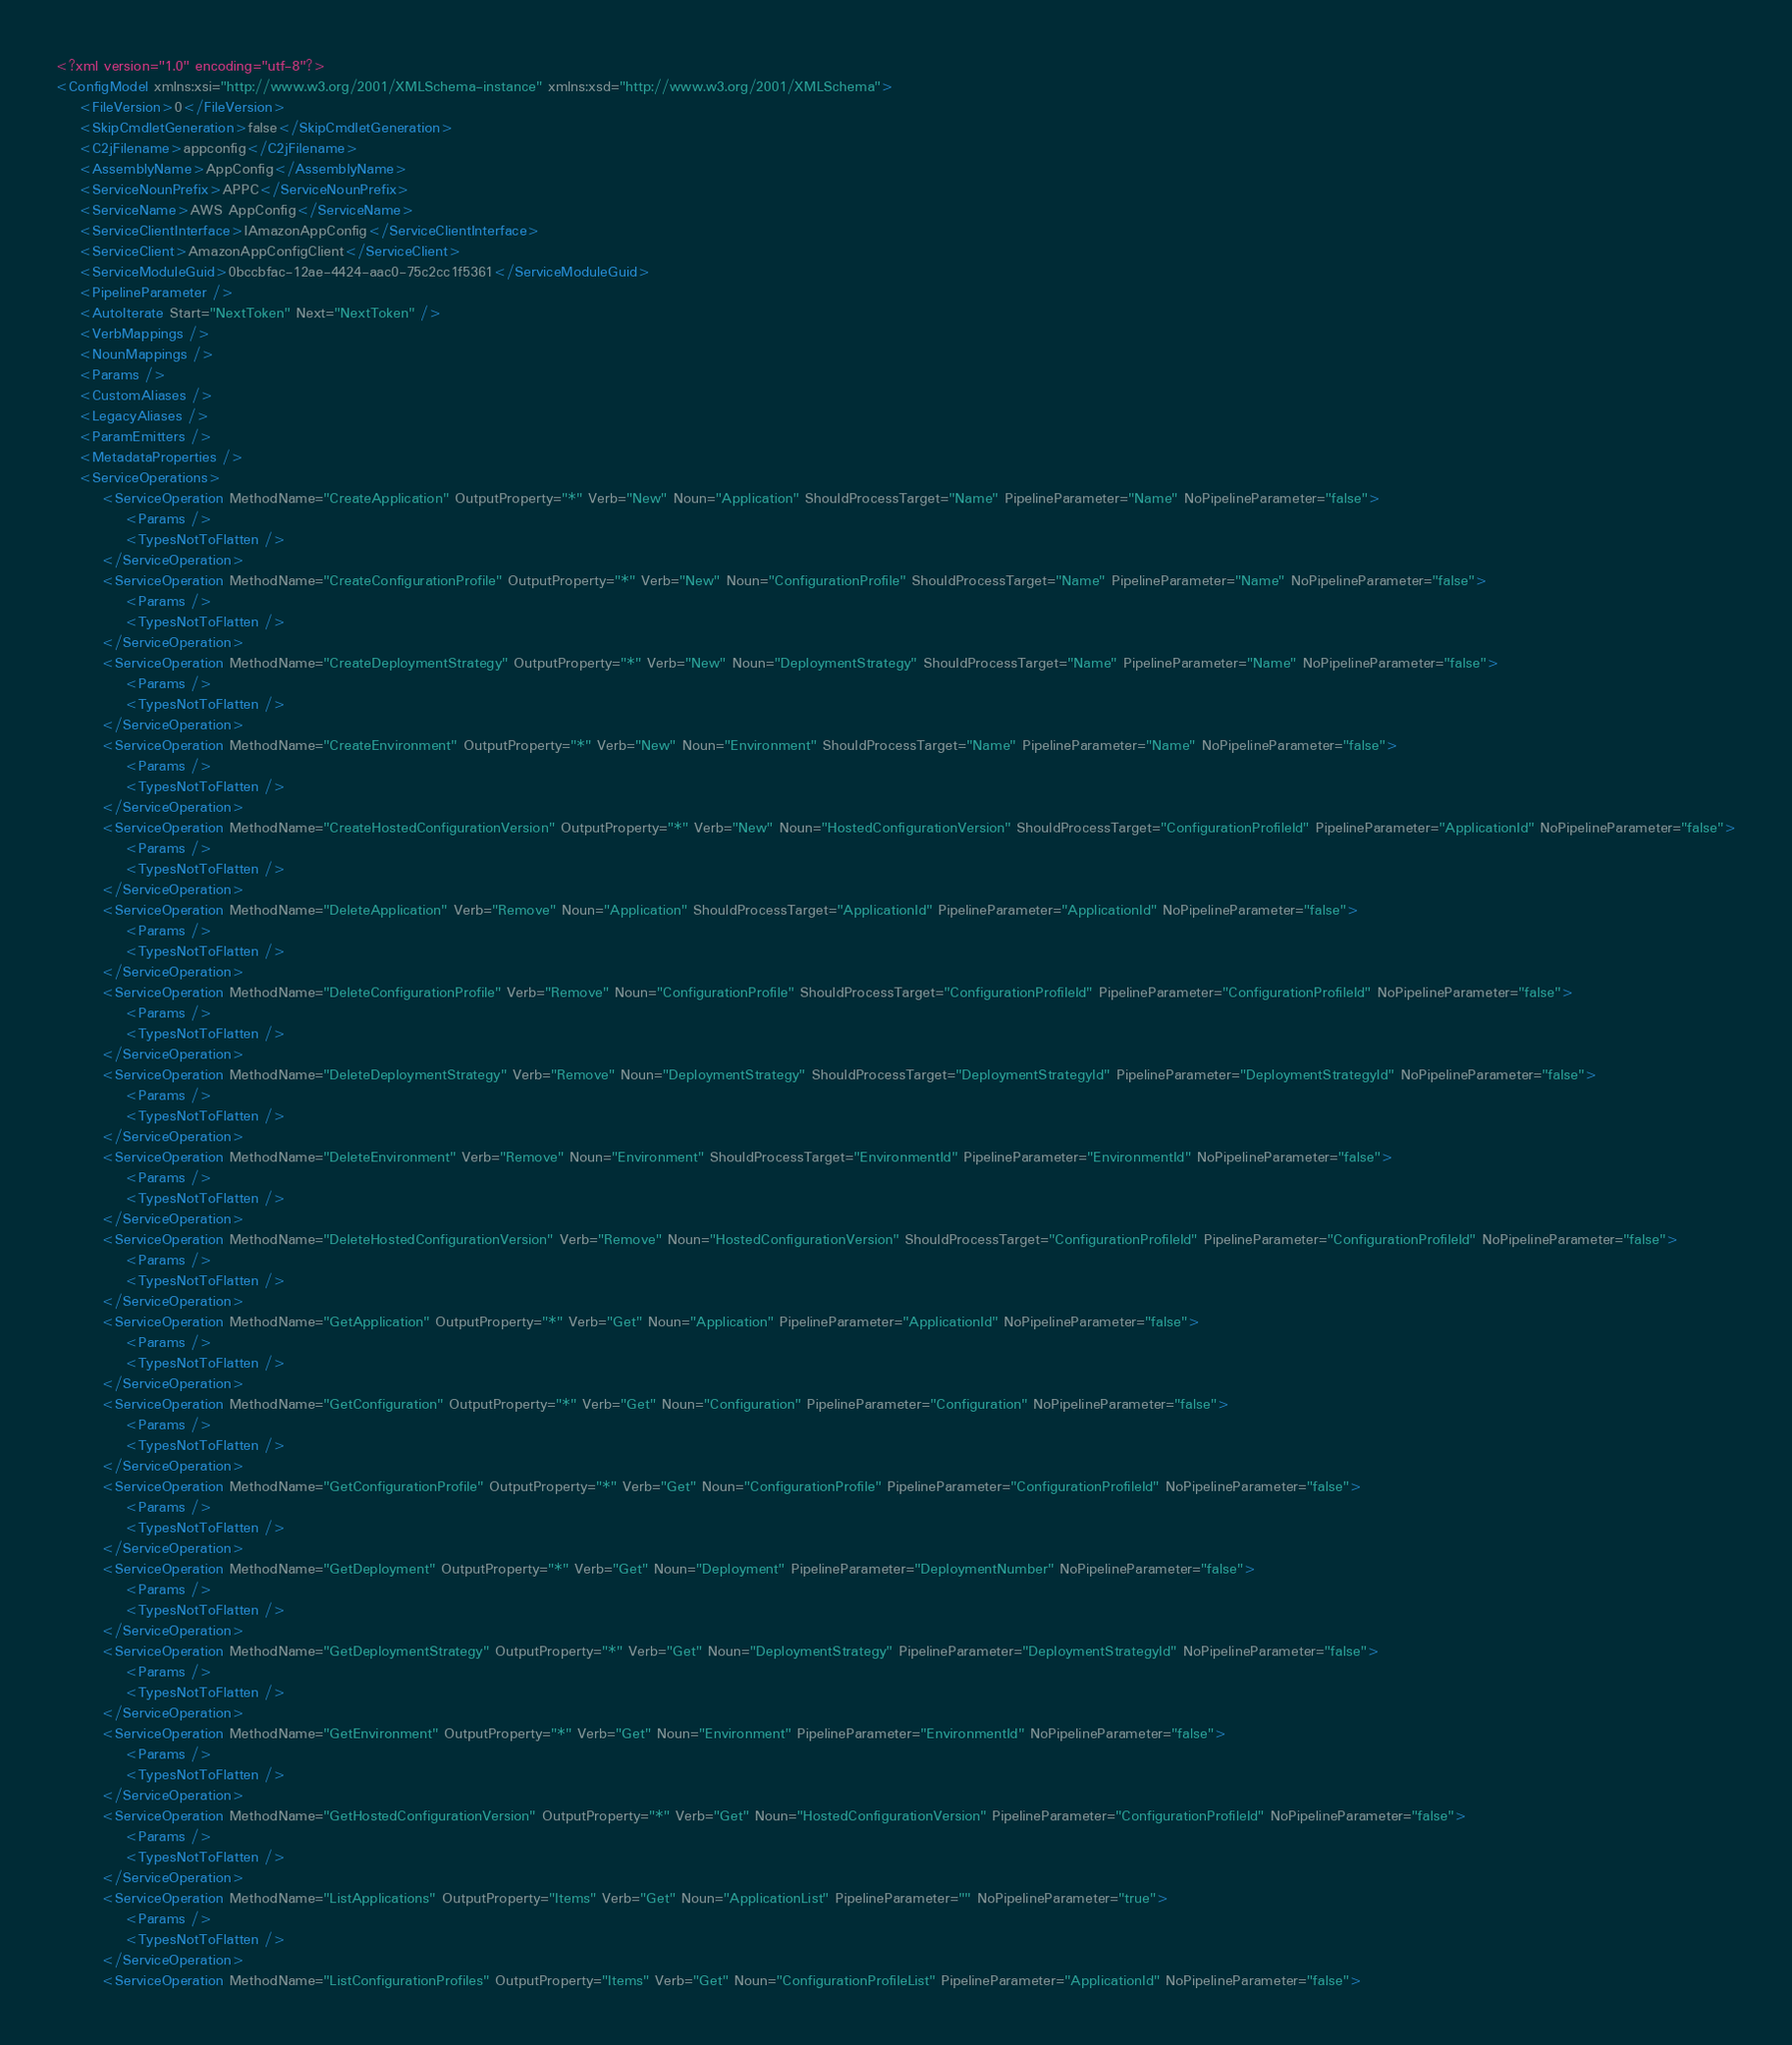<code> <loc_0><loc_0><loc_500><loc_500><_XML_><?xml version="1.0" encoding="utf-8"?>
<ConfigModel xmlns:xsi="http://www.w3.org/2001/XMLSchema-instance" xmlns:xsd="http://www.w3.org/2001/XMLSchema">
    <FileVersion>0</FileVersion>
    <SkipCmdletGeneration>false</SkipCmdletGeneration>
    <C2jFilename>appconfig</C2jFilename>
    <AssemblyName>AppConfig</AssemblyName>
    <ServiceNounPrefix>APPC</ServiceNounPrefix>
    <ServiceName>AWS AppConfig</ServiceName>
    <ServiceClientInterface>IAmazonAppConfig</ServiceClientInterface>
    <ServiceClient>AmazonAppConfigClient</ServiceClient>
    <ServiceModuleGuid>0bccbfac-12ae-4424-aac0-75c2cc1f5361</ServiceModuleGuid>
    <PipelineParameter />
    <AutoIterate Start="NextToken" Next="NextToken" />
    <VerbMappings />
    <NounMappings />
    <Params />
    <CustomAliases />
    <LegacyAliases />
    <ParamEmitters />
    <MetadataProperties />
    <ServiceOperations>
        <ServiceOperation MethodName="CreateApplication" OutputProperty="*" Verb="New" Noun="Application" ShouldProcessTarget="Name" PipelineParameter="Name" NoPipelineParameter="false">
            <Params />
            <TypesNotToFlatten />
        </ServiceOperation>
        <ServiceOperation MethodName="CreateConfigurationProfile" OutputProperty="*" Verb="New" Noun="ConfigurationProfile" ShouldProcessTarget="Name" PipelineParameter="Name" NoPipelineParameter="false">
            <Params />
            <TypesNotToFlatten />
        </ServiceOperation>
        <ServiceOperation MethodName="CreateDeploymentStrategy" OutputProperty="*" Verb="New" Noun="DeploymentStrategy" ShouldProcessTarget="Name" PipelineParameter="Name" NoPipelineParameter="false">
            <Params />
            <TypesNotToFlatten />
        </ServiceOperation>
        <ServiceOperation MethodName="CreateEnvironment" OutputProperty="*" Verb="New" Noun="Environment" ShouldProcessTarget="Name" PipelineParameter="Name" NoPipelineParameter="false">
            <Params />
            <TypesNotToFlatten />
        </ServiceOperation>
        <ServiceOperation MethodName="CreateHostedConfigurationVersion" OutputProperty="*" Verb="New" Noun="HostedConfigurationVersion" ShouldProcessTarget="ConfigurationProfileId" PipelineParameter="ApplicationId" NoPipelineParameter="false">
            <Params />
            <TypesNotToFlatten />
        </ServiceOperation>
        <ServiceOperation MethodName="DeleteApplication" Verb="Remove" Noun="Application" ShouldProcessTarget="ApplicationId" PipelineParameter="ApplicationId" NoPipelineParameter="false">
            <Params />
            <TypesNotToFlatten />
        </ServiceOperation>
        <ServiceOperation MethodName="DeleteConfigurationProfile" Verb="Remove" Noun="ConfigurationProfile" ShouldProcessTarget="ConfigurationProfileId" PipelineParameter="ConfigurationProfileId" NoPipelineParameter="false">
            <Params />
            <TypesNotToFlatten />
        </ServiceOperation>
        <ServiceOperation MethodName="DeleteDeploymentStrategy" Verb="Remove" Noun="DeploymentStrategy" ShouldProcessTarget="DeploymentStrategyId" PipelineParameter="DeploymentStrategyId" NoPipelineParameter="false">
            <Params />
            <TypesNotToFlatten />
        </ServiceOperation>
        <ServiceOperation MethodName="DeleteEnvironment" Verb="Remove" Noun="Environment" ShouldProcessTarget="EnvironmentId" PipelineParameter="EnvironmentId" NoPipelineParameter="false">
            <Params />
            <TypesNotToFlatten />
        </ServiceOperation>
        <ServiceOperation MethodName="DeleteHostedConfigurationVersion" Verb="Remove" Noun="HostedConfigurationVersion" ShouldProcessTarget="ConfigurationProfileId" PipelineParameter="ConfigurationProfileId" NoPipelineParameter="false">
            <Params />
            <TypesNotToFlatten />
        </ServiceOperation>
        <ServiceOperation MethodName="GetApplication" OutputProperty="*" Verb="Get" Noun="Application" PipelineParameter="ApplicationId" NoPipelineParameter="false">
            <Params />
            <TypesNotToFlatten />
        </ServiceOperation>
        <ServiceOperation MethodName="GetConfiguration" OutputProperty="*" Verb="Get" Noun="Configuration" PipelineParameter="Configuration" NoPipelineParameter="false">
            <Params />
            <TypesNotToFlatten />
        </ServiceOperation>
        <ServiceOperation MethodName="GetConfigurationProfile" OutputProperty="*" Verb="Get" Noun="ConfigurationProfile" PipelineParameter="ConfigurationProfileId" NoPipelineParameter="false">
            <Params />
            <TypesNotToFlatten />
        </ServiceOperation>
        <ServiceOperation MethodName="GetDeployment" OutputProperty="*" Verb="Get" Noun="Deployment" PipelineParameter="DeploymentNumber" NoPipelineParameter="false">
            <Params />
            <TypesNotToFlatten />
        </ServiceOperation>
        <ServiceOperation MethodName="GetDeploymentStrategy" OutputProperty="*" Verb="Get" Noun="DeploymentStrategy" PipelineParameter="DeploymentStrategyId" NoPipelineParameter="false">
            <Params />
            <TypesNotToFlatten />
        </ServiceOperation>
        <ServiceOperation MethodName="GetEnvironment" OutputProperty="*" Verb="Get" Noun="Environment" PipelineParameter="EnvironmentId" NoPipelineParameter="false">
            <Params />
            <TypesNotToFlatten />
        </ServiceOperation>
        <ServiceOperation MethodName="GetHostedConfigurationVersion" OutputProperty="*" Verb="Get" Noun="HostedConfigurationVersion" PipelineParameter="ConfigurationProfileId" NoPipelineParameter="false">
            <Params />
            <TypesNotToFlatten />
        </ServiceOperation>
        <ServiceOperation MethodName="ListApplications" OutputProperty="Items" Verb="Get" Noun="ApplicationList" PipelineParameter="" NoPipelineParameter="true">
            <Params />
            <TypesNotToFlatten />
        </ServiceOperation>
        <ServiceOperation MethodName="ListConfigurationProfiles" OutputProperty="Items" Verb="Get" Noun="ConfigurationProfileList" PipelineParameter="ApplicationId" NoPipelineParameter="false"></code> 